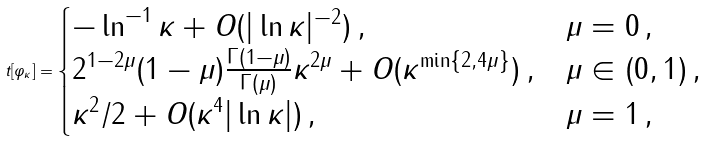Convert formula to latex. <formula><loc_0><loc_0><loc_500><loc_500>t [ \varphi _ { \kappa } ] = \begin{cases} - \ln ^ { - 1 } \kappa + O ( | \ln \kappa | ^ { - 2 } ) \, , & \mu = 0 \, , \\ 2 ^ { 1 - 2 \mu } ( 1 - \mu ) \frac { \Gamma ( 1 - \mu ) } { \Gamma ( \mu ) } \kappa ^ { 2 \mu } + O ( \kappa ^ { \min \{ 2 , 4 \mu \} } ) \, , & \mu \in ( 0 , 1 ) \, , \\ \kappa ^ { 2 } / 2 + O ( \kappa ^ { 4 } | \ln \kappa | ) \, , & \mu = 1 \, , \end{cases}</formula> 